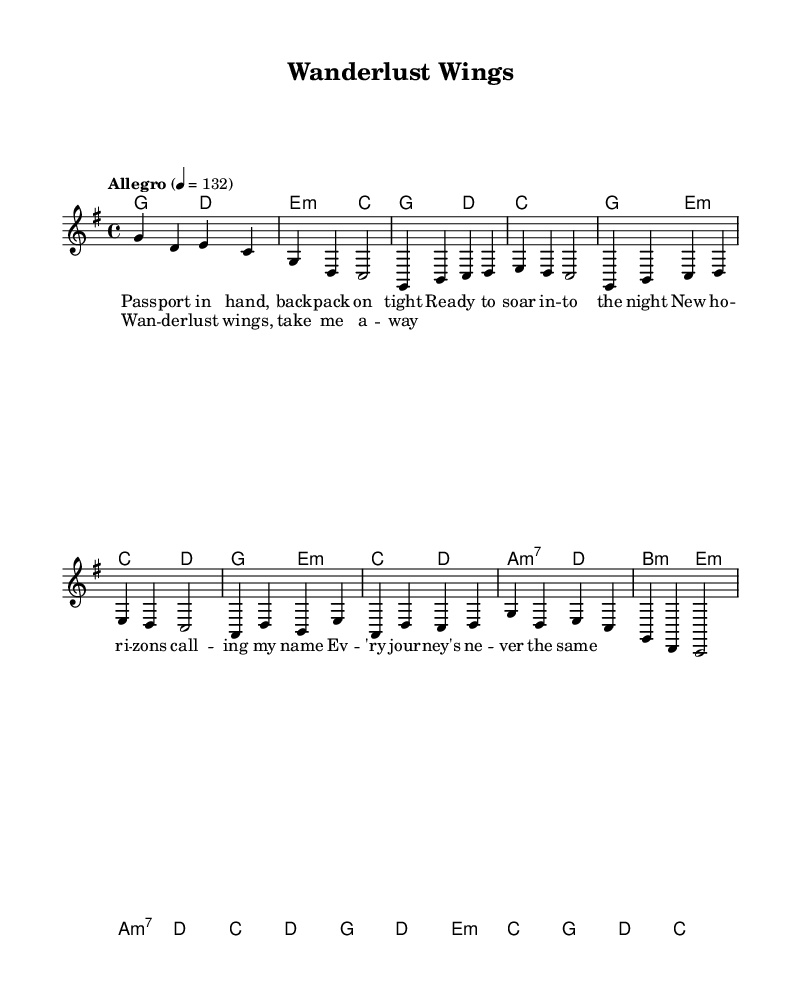What is the key signature of this music? The key signature is G major, which has one sharp (F#), indicated by its placement at the beginning of the staff.
Answer: G major What is the time signature of this piece? The time signature is 4/4, shown at the beginning of the score, indicating four beats per measure and a quarter note receives one beat.
Answer: 4/4 What is the tempo marking of this piece? The tempo marking is "Allegro" at 132 beats per minute, denoting a fast and lively pace.
Answer: Allegro How many measures are in the verse section? The verse consists of four measures, as indicated by the grouping of the notes and rests in that section.
Answer: 4 What harmonic progression is used in the intro? The harmonic progression in the intro follows a G to D to E minor to C sequence. This can be seen in the chord symbols written above the staff.
Answer: G, D, E minor, C Which section features the lyrics "Wanderlust wings, take me away"? This phrase is found in the chorus section of the song, as indicated by its placement and the lyric association in the score.
Answer: Chorus 